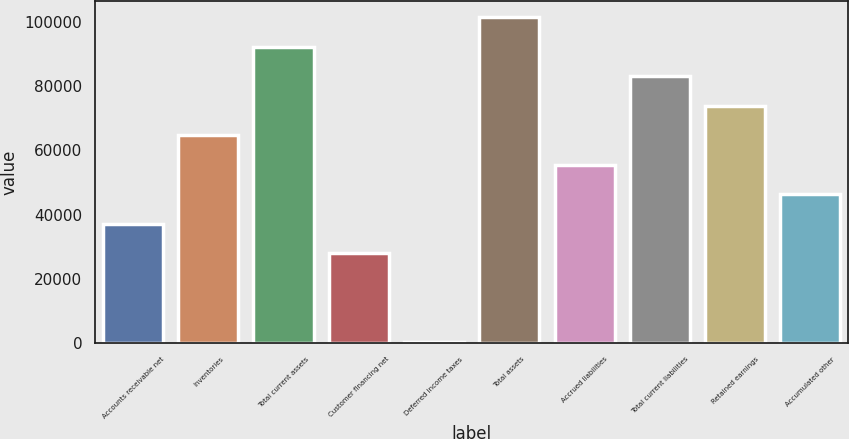Convert chart. <chart><loc_0><loc_0><loc_500><loc_500><bar_chart><fcel>Accounts receivable net<fcel>Inventories<fcel>Total current assets<fcel>Customer financing net<fcel>Deferred income taxes<fcel>Total assets<fcel>Accrued liabilities<fcel>Total current liabilities<fcel>Retained earnings<fcel>Accumulated other<nl><fcel>37137.8<fcel>64735.4<fcel>92333<fcel>27938.6<fcel>341<fcel>101532<fcel>55536.2<fcel>83133.8<fcel>73934.6<fcel>46337<nl></chart> 